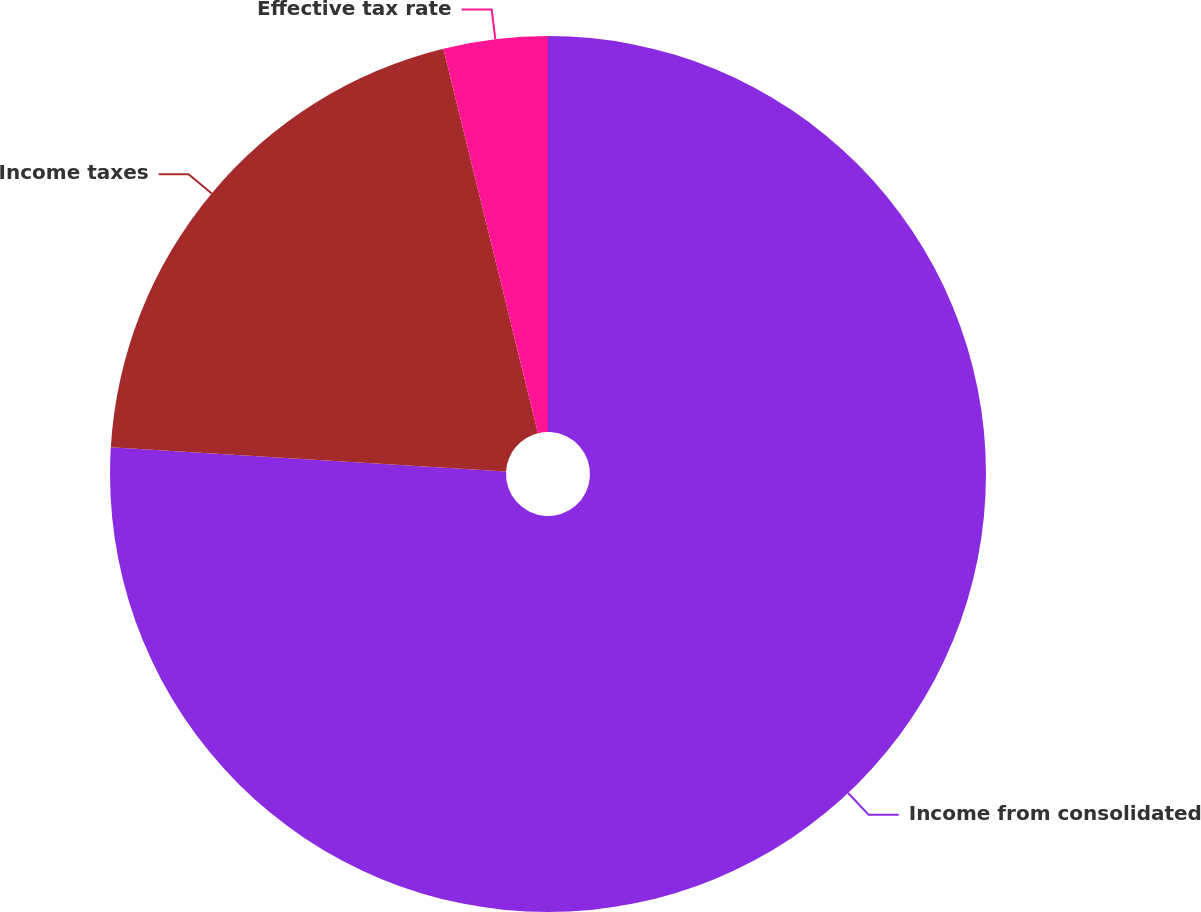<chart> <loc_0><loc_0><loc_500><loc_500><pie_chart><fcel>Income from consolidated<fcel>Income taxes<fcel>Effective tax rate<nl><fcel>75.97%<fcel>20.19%<fcel>3.84%<nl></chart> 